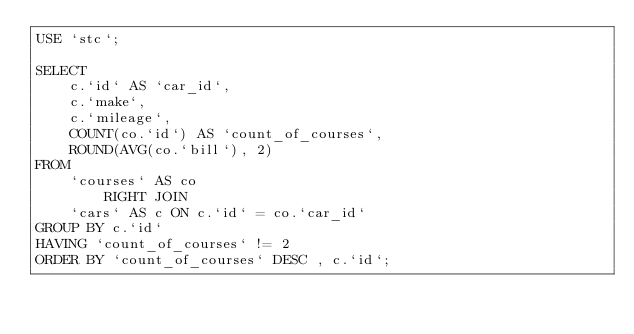<code> <loc_0><loc_0><loc_500><loc_500><_SQL_>USE `stc`;

SELECT 
    c.`id` AS `car_id`,
    c.`make`,
    c.`mileage`,
    COUNT(co.`id`) AS `count_of_courses`,
    ROUND(AVG(co.`bill`), 2)
FROM
    `courses` AS co
        RIGHT JOIN
    `cars` AS c ON c.`id` = co.`car_id`
GROUP BY c.`id`
HAVING `count_of_courses` != 2
ORDER BY `count_of_courses` DESC , c.`id`;</code> 